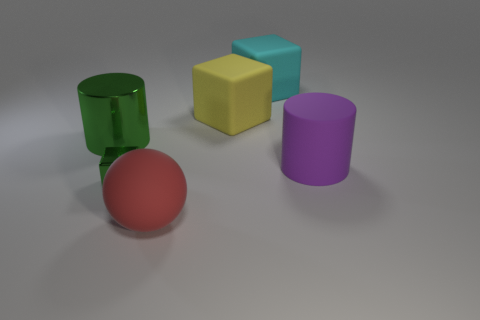What shape is the purple thing that is the same material as the yellow object?
Ensure brevity in your answer.  Cylinder. There is a green object in front of the large green cylinder; are there any purple things in front of it?
Keep it short and to the point. No. How many things are big cylinders on the right side of the green cylinder or large gray spheres?
Your answer should be compact. 1. Is there any other thing that has the same size as the purple rubber thing?
Offer a very short reply. Yes. There is a cylinder that is on the right side of the green object that is behind the tiny green metal thing; what is it made of?
Give a very brief answer. Rubber. Is the number of big cyan objects behind the large cyan matte block the same as the number of big rubber balls that are to the left of the big purple rubber thing?
Provide a succinct answer. No. What number of objects are either rubber things that are in front of the tiny green object or big objects that are to the right of the green metal cylinder?
Offer a terse response. 4. What is the large thing that is in front of the big green metal cylinder and to the right of the red rubber sphere made of?
Your answer should be very brief. Rubber. What is the size of the cylinder right of the cyan thing on the left side of the big matte cylinder to the right of the small object?
Offer a terse response. Large. Are there more rubber cubes than blue matte things?
Your answer should be compact. Yes. 